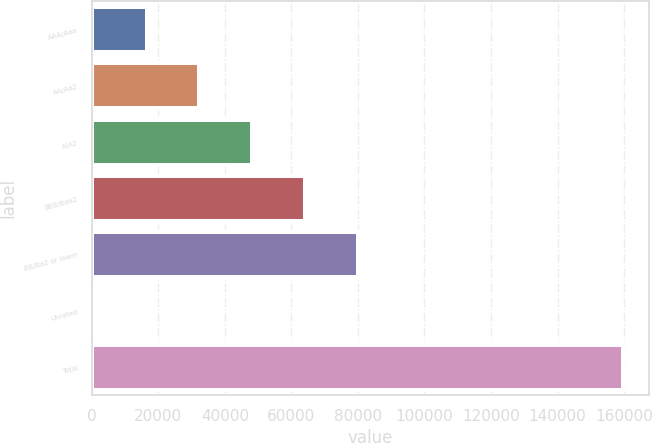Convert chart to OTSL. <chart><loc_0><loc_0><loc_500><loc_500><bar_chart><fcel>AAA/Aaa<fcel>AA/Aa2<fcel>A/A2<fcel>BBB/Baa2<fcel>BB/Ba2 or lower<fcel>Unrated<fcel>Total<nl><fcel>16446.2<fcel>32352.4<fcel>48258.6<fcel>64164.8<fcel>80071<fcel>540<fcel>159602<nl></chart> 